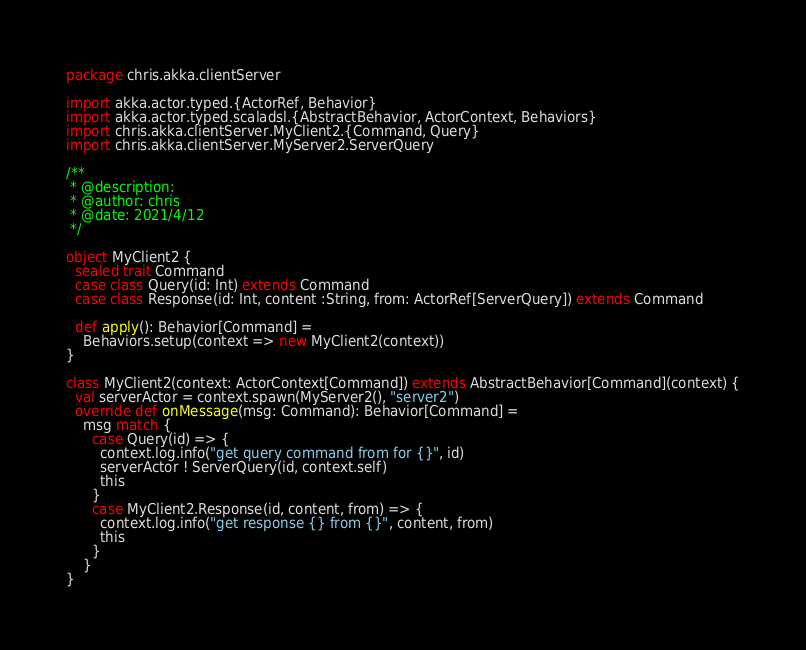Convert code to text. <code><loc_0><loc_0><loc_500><loc_500><_Scala_>package chris.akka.clientServer

import akka.actor.typed.{ActorRef, Behavior}
import akka.actor.typed.scaladsl.{AbstractBehavior, ActorContext, Behaviors}
import chris.akka.clientServer.MyClient2.{Command, Query}
import chris.akka.clientServer.MyServer2.ServerQuery

/**
 * @description:
 * @author: chris
 * @date: 2021/4/12
 */

object MyClient2 {
  sealed trait Command
  case class Query(id: Int) extends Command
  case class Response(id: Int, content :String, from: ActorRef[ServerQuery]) extends Command

  def apply(): Behavior[Command] =
    Behaviors.setup(context => new MyClient2(context))
}

class MyClient2(context: ActorContext[Command]) extends AbstractBehavior[Command](context) {
  val serverActor = context.spawn(MyServer2(), "server2")
  override def onMessage(msg: Command): Behavior[Command] =
    msg match {
      case Query(id) => {
        context.log.info("get query command from for {}", id)
        serverActor ! ServerQuery(id, context.self)
        this
      }
      case MyClient2.Response(id, content, from) => {
        context.log.info("get response {} from {}", content, from)
        this
      }
    }
}
</code> 